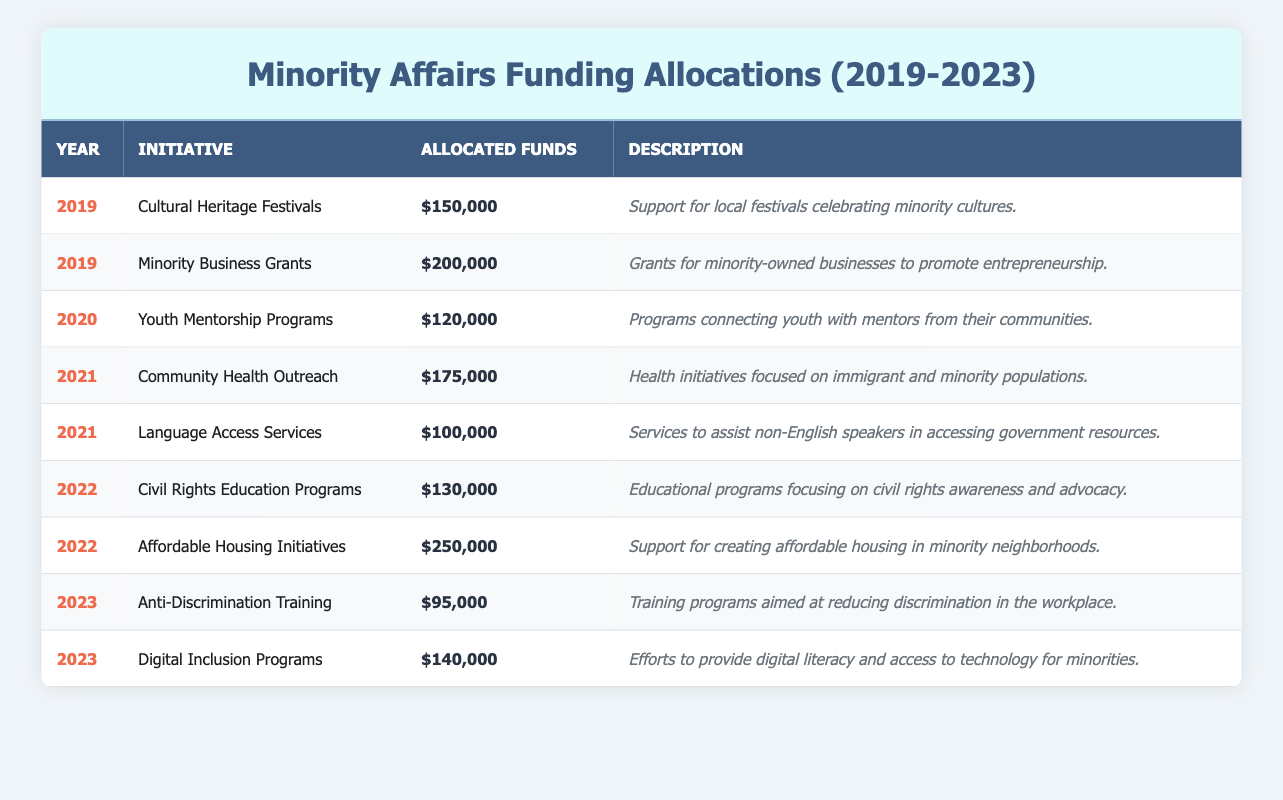What was the total amount allocated for initiatives in 2021? In 2021, there are two initiatives with allocated funds: Community Health Outreach ($175,000) and Language Access Services ($100,000). To find the total allocation for that year, we add these two amounts: 175000 + 100000 = 275000.
Answer: 275000 Which initiative received the highest funding in 2022? The initiatives for 2022 are Civil Rights Education Programs ($130,000) and Affordable Housing Initiatives ($250,000). The Affordable Housing Initiatives received the higher amount of $250,000.
Answer: Affordable Housing Initiatives Was there any funding allocated for Youth Mentorship Programs in 2019? Youth Mentorship Programs were allocated funds in 2020 ($120,000) and not in 2019. Therefore, there was no funding for Youth Mentorship Programs in 2019.
Answer: No What is the total funding allocated to Cultural Heritage Festivals and Minority Business Grants combined? Cultural Heritage Festivals received $150,000, and Minority Business Grants received $200,000 in 2019. Adding these two amounts gives us: 150000 + 200000 = 350000.
Answer: 350000 Is the funding allocation for Digital Inclusion Programs higher than that for Anti-Discrimination Training in 2023? Digital Inclusion Programs received $140,000, while Anti-Discrimination Training received $95,000 in 2023. Since 140000 is greater than 95000, the funding allocation for Digital Inclusion Programs is higher.
Answer: Yes What was the average funding allocation per initiative in 2019? In 2019, there were two initiatives: Cultural Heritage Festivals ($150,000) and Minority Business Grants ($200,000). To find the average funding allocation, we first sum the two allocations: 150000 + 200000 = 350000. Then, divide by the number of initiatives (2): 350000 / 2 = 175000.
Answer: 175000 Which year had the least amount of funding allocated overall? To find the year with the least funding, we sum the allocations for each year: 2019 (350000), 2020 (120000), 2021 (275000), 2022 (380000), and 2023 (235000). The least amount is from 2020, which had a total of $120,000.
Answer: 2020 Did the funding for Language Access Services exceed the amount allocated for Anti-Discrimination Training? Language Access Services received $100,000 allocated in 2021, while Anti-Discrimination Training had $95,000 allocated in 2023. Since $100,000 is greater than $95,000, the funding for Language Access Services exceeded that of Anti-Discrimination Training.
Answer: Yes 